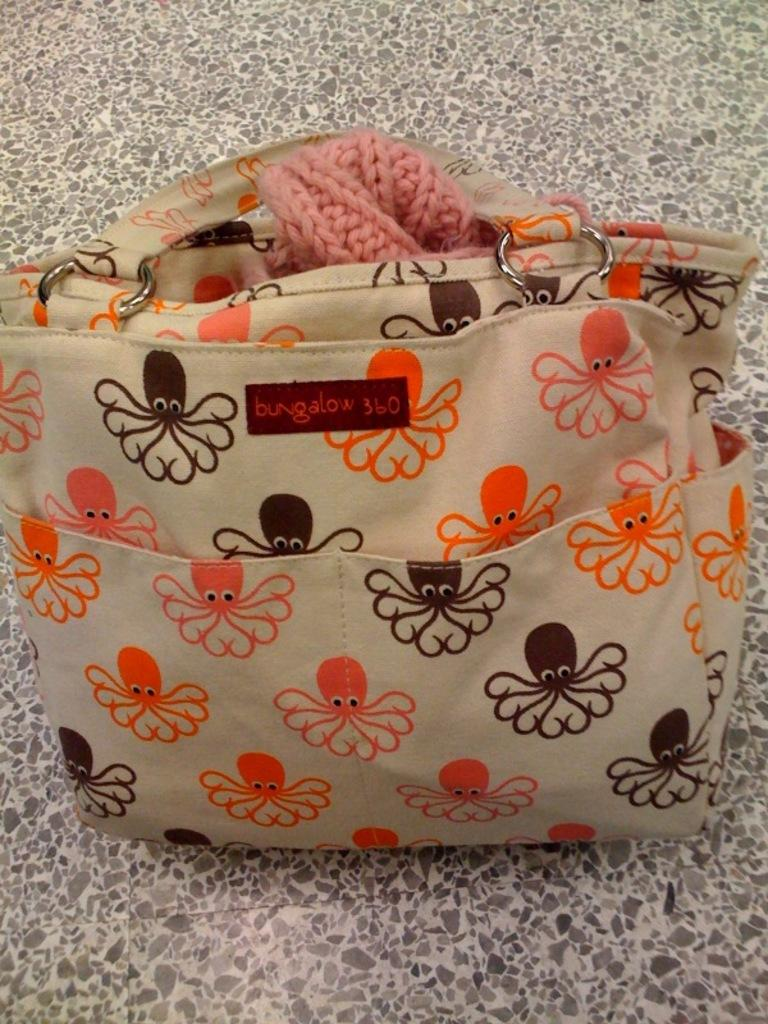What type of object is depicted in the image? The object is a handbag. Can you describe the appearance of the handbag? There are designs on the handbag. Is there a snake slithering around the handbag in the image? No, there is no snake present in the image. What type of activity is the handbag participating in within the image? The handbag is an inanimate object and cannot participate in any activities. 